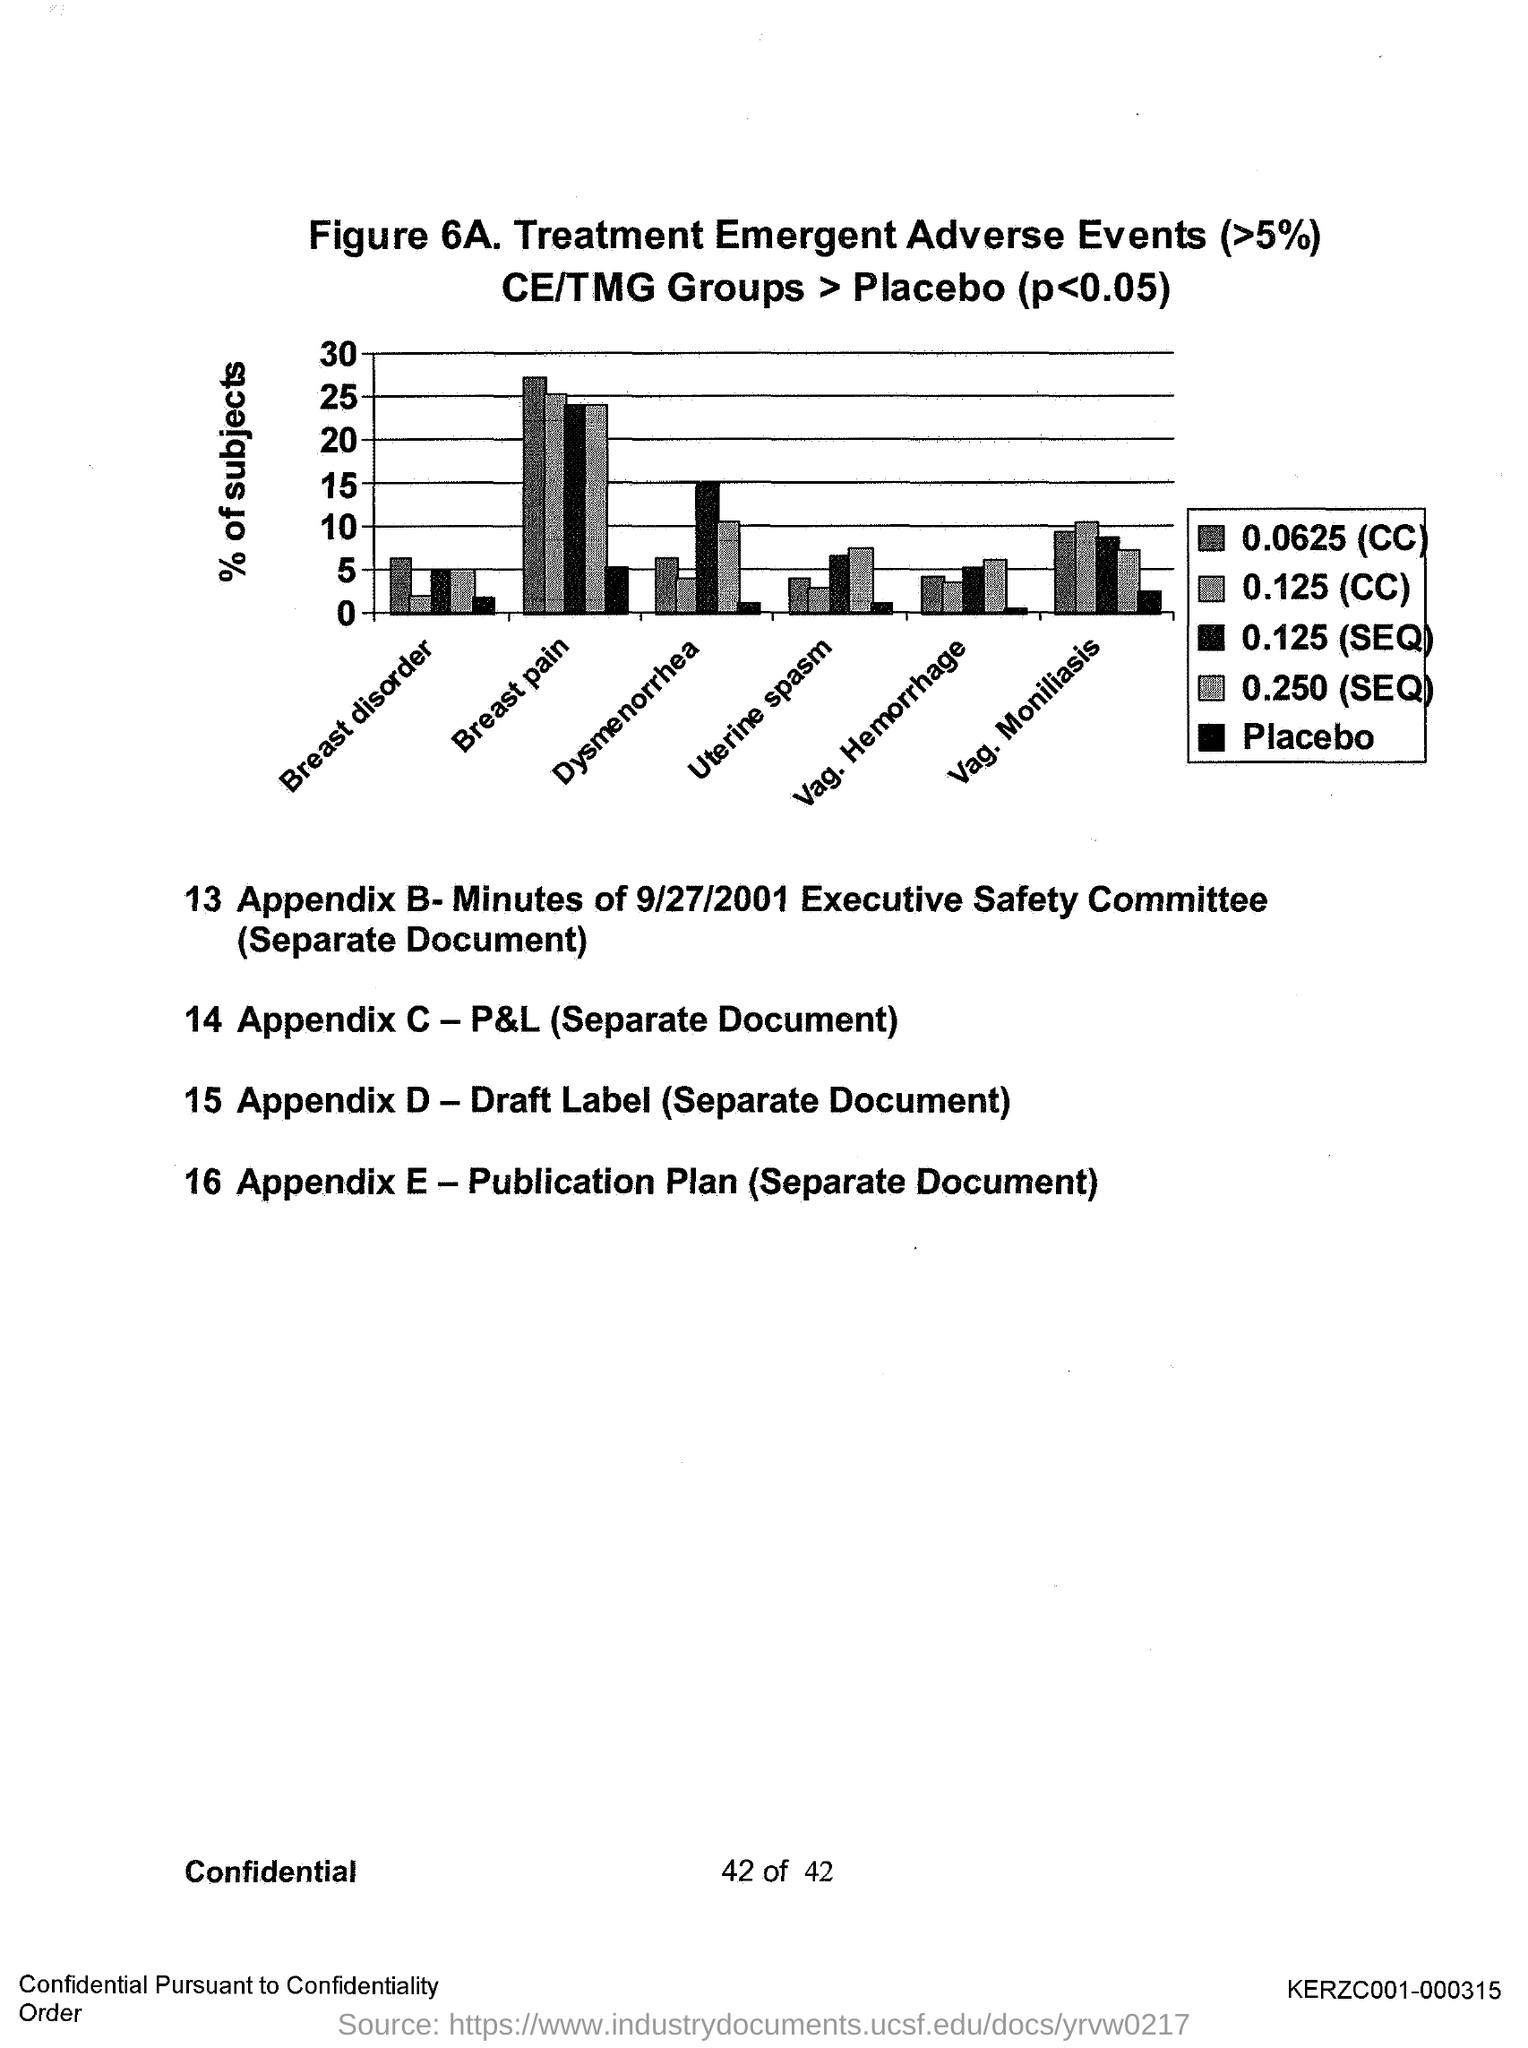What is the figure number?
Provide a short and direct response. 6A. What is plotted on the y-axis?
Make the answer very short. % of subjects. 